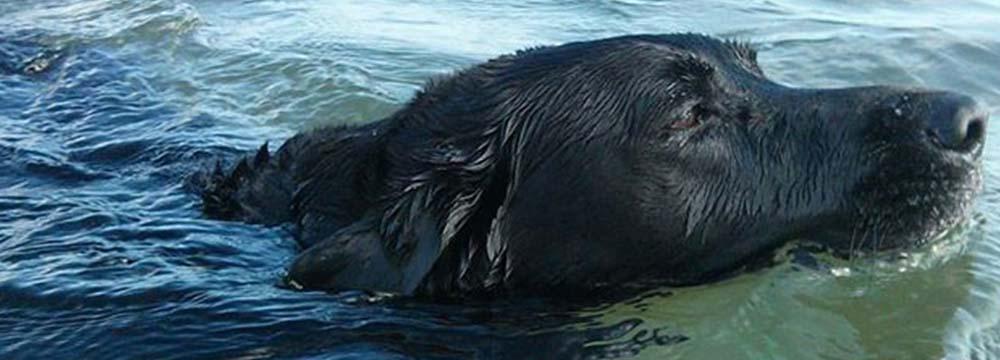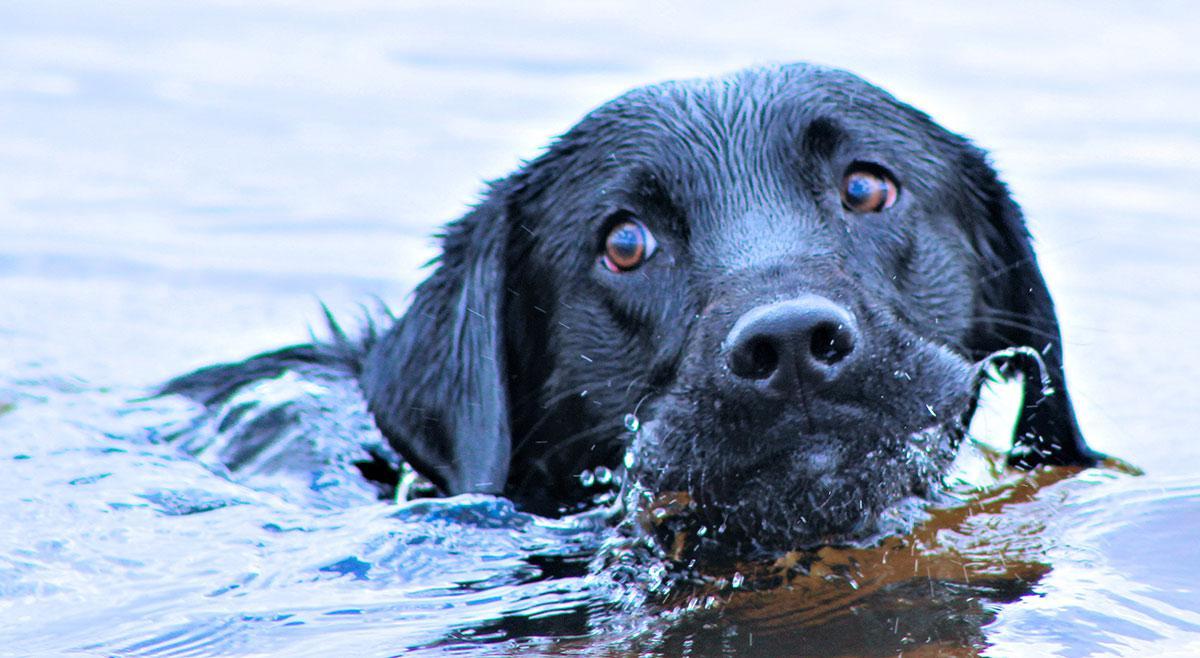The first image is the image on the left, the second image is the image on the right. Analyze the images presented: Is the assertion "At least one dog has it's tail out of the water." valid? Answer yes or no. No. The first image is the image on the left, the second image is the image on the right. Assess this claim about the two images: "In one image the dog is facing forward, and in the other it is facing to the side.". Correct or not? Answer yes or no. Yes. 